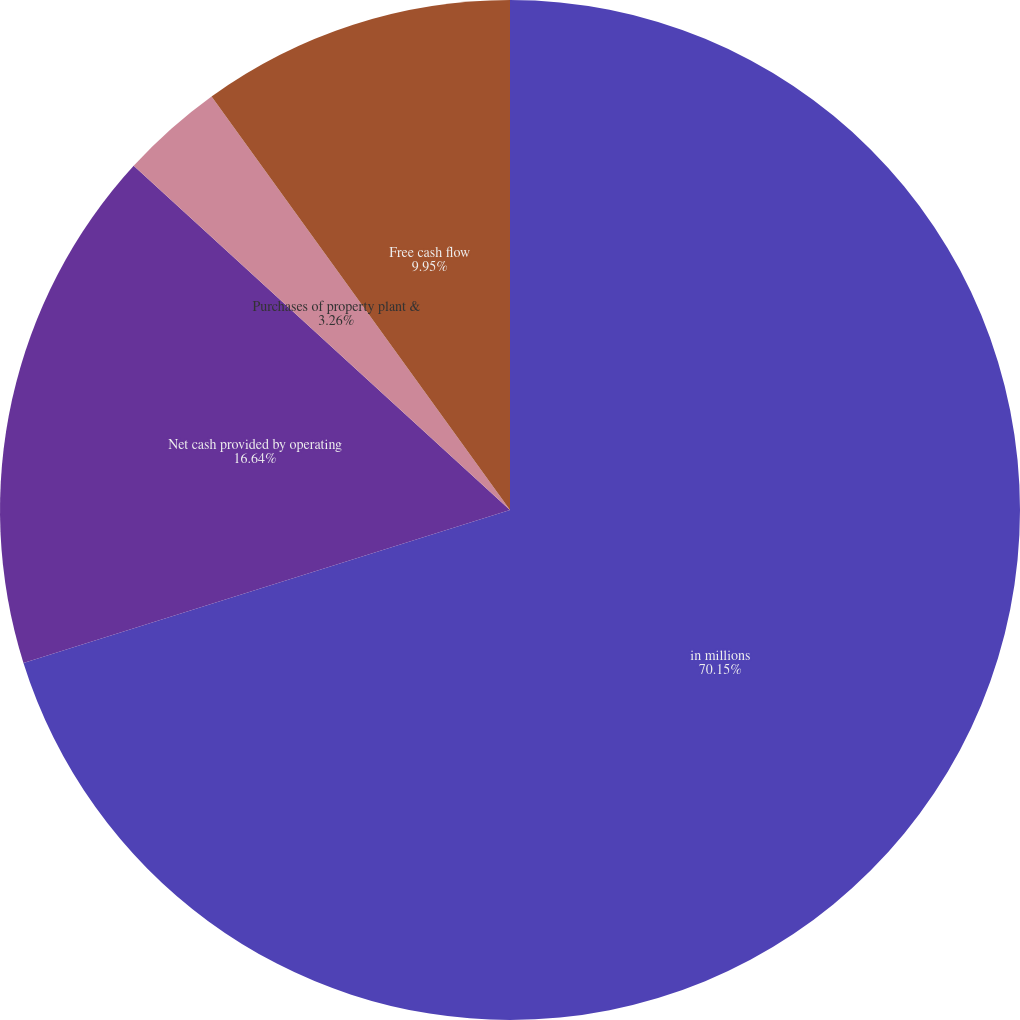<chart> <loc_0><loc_0><loc_500><loc_500><pie_chart><fcel>in millions<fcel>Net cash provided by operating<fcel>Purchases of property plant &<fcel>Free cash flow<nl><fcel>70.16%<fcel>16.64%<fcel>3.26%<fcel>9.95%<nl></chart> 